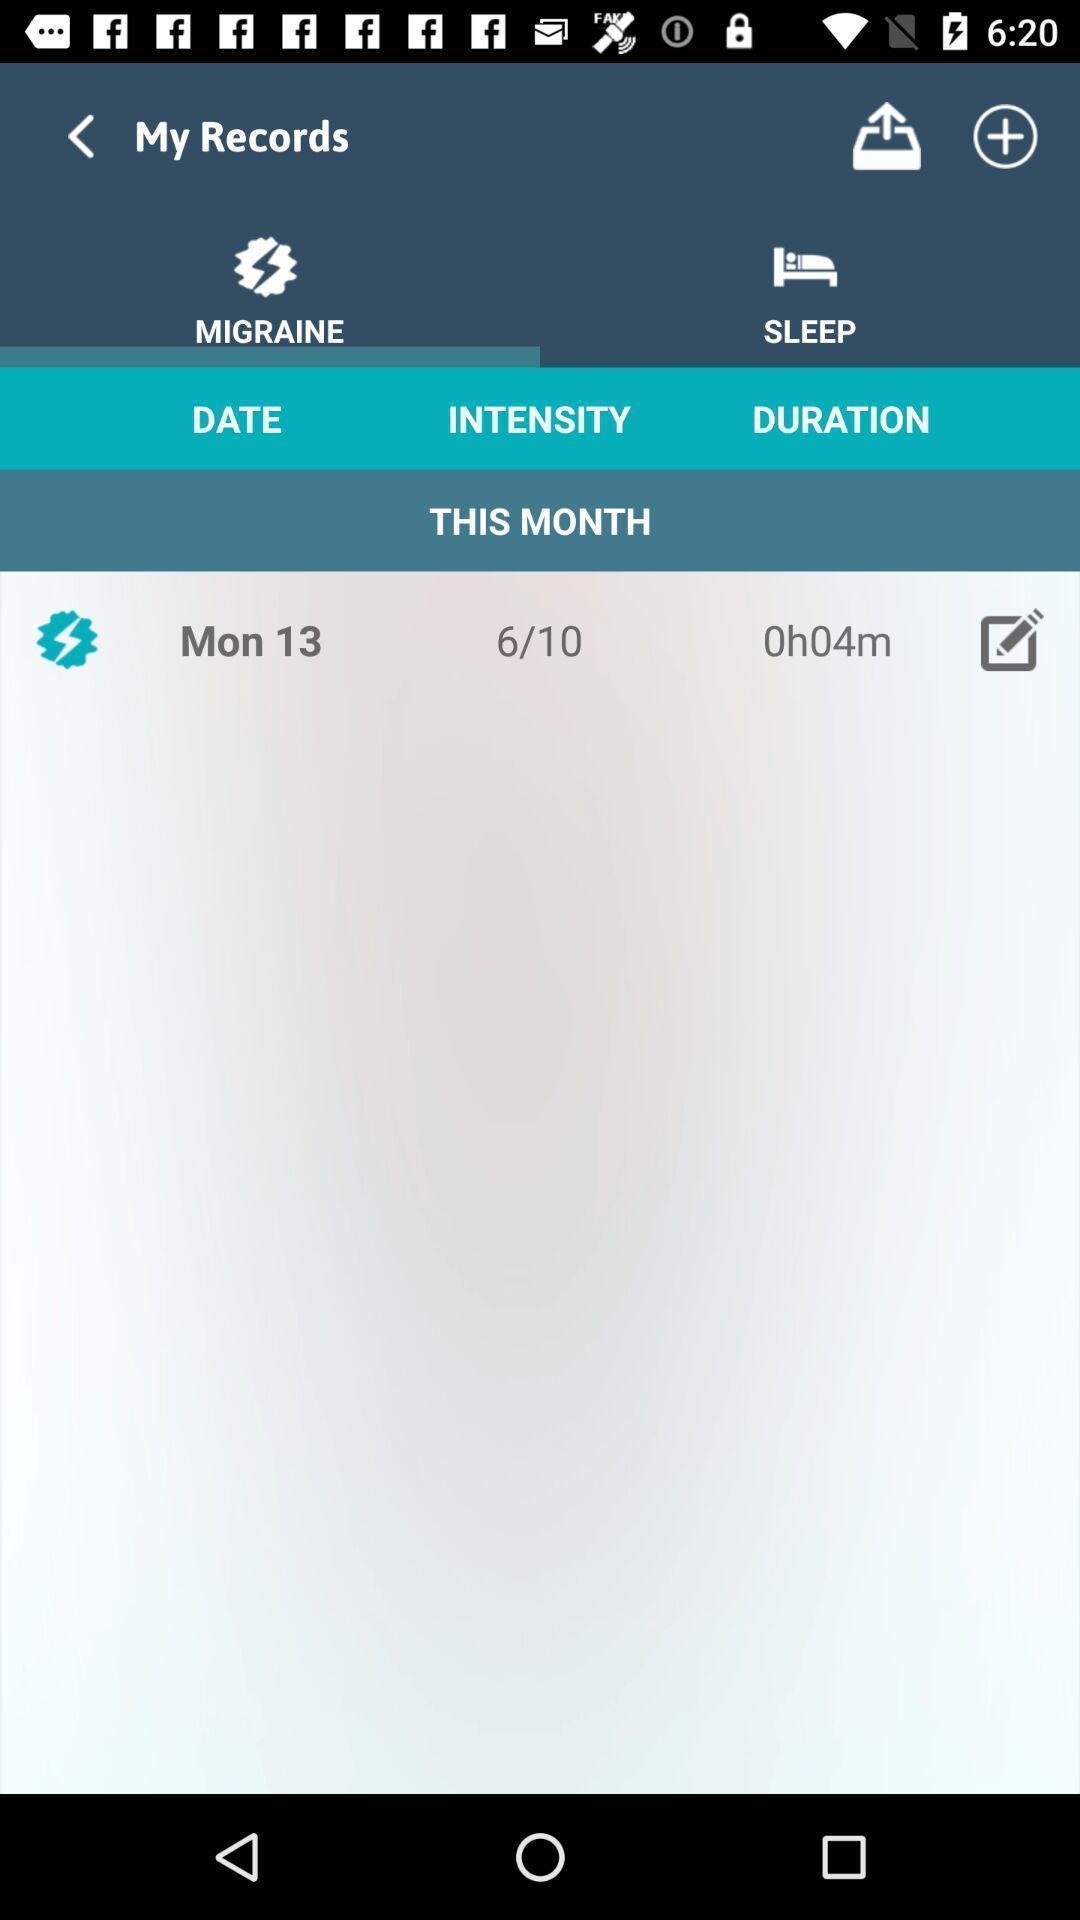Explain what's happening in this screen capture. Page showing the records of daily activities. 